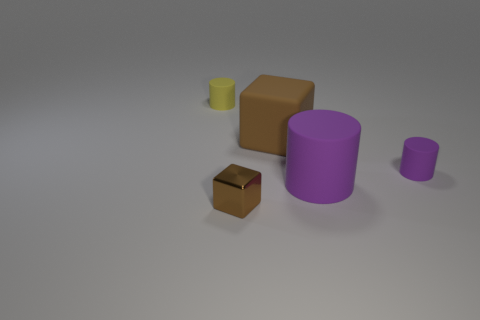There is a big cylinder; is its color the same as the tiny cylinder that is on the right side of the small yellow rubber cylinder?
Offer a very short reply. Yes. Are there an equal number of matte cylinders behind the large purple matte cylinder and cylinders to the right of the brown rubber thing?
Your answer should be compact. Yes. There is a small cylinder in front of the yellow cylinder; what is it made of?
Your answer should be very brief. Rubber. What number of things are either small matte objects that are on the right side of the yellow cylinder or yellow metal blocks?
Your answer should be very brief. 1. What number of other things are there of the same shape as the tiny brown object?
Your answer should be very brief. 1. There is a brown object in front of the rubber block; is it the same shape as the large brown thing?
Keep it short and to the point. Yes. There is a brown metallic object; are there any yellow objects behind it?
Provide a short and direct response. Yes. How many tiny things are either brown blocks or metal things?
Ensure brevity in your answer.  1. Does the big purple object have the same material as the big brown thing?
Ensure brevity in your answer.  Yes. There is a block that is the same color as the shiny thing; what is its size?
Ensure brevity in your answer.  Large. 